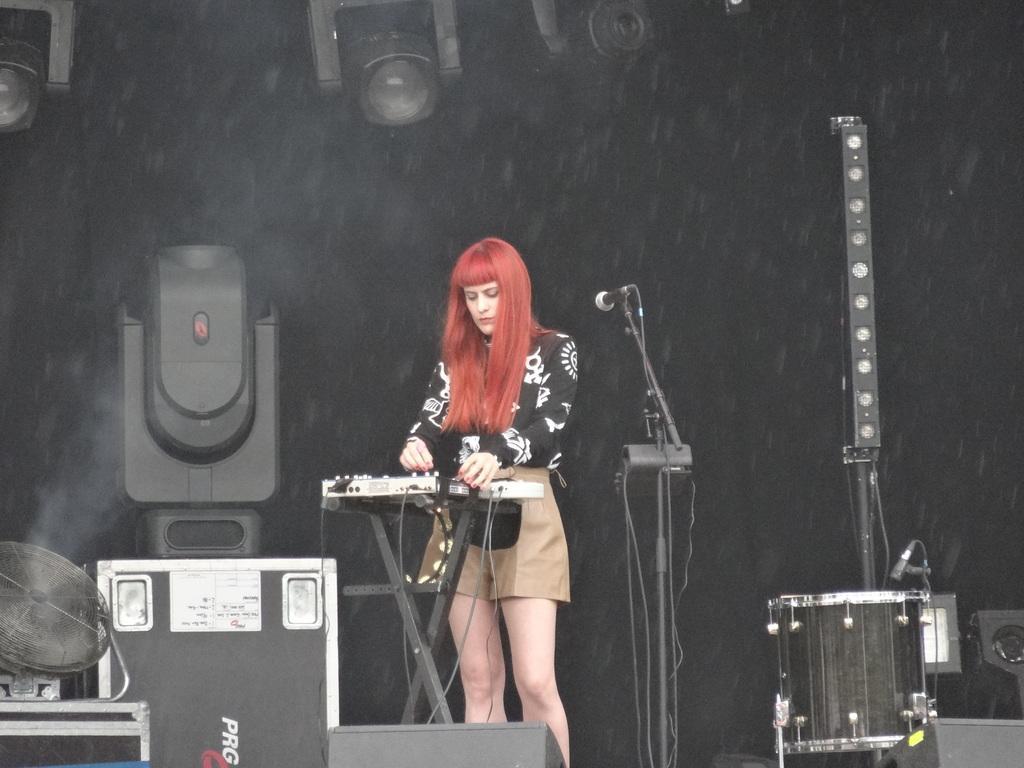Describe this image in one or two sentences. At the bottom of the image there are some musical instruments and drums and microphone. Behind them a woman is standing. Behind the women there are some speakers and wall. 